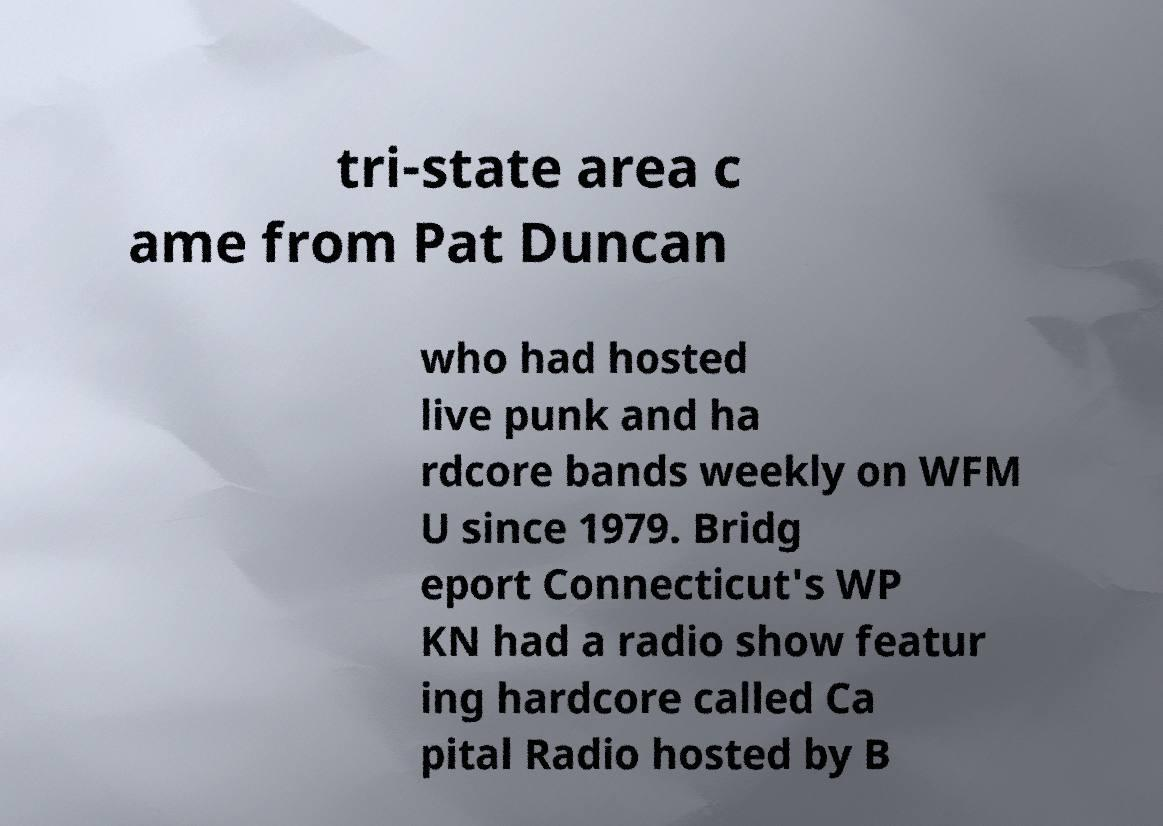Could you extract and type out the text from this image? tri-state area c ame from Pat Duncan who had hosted live punk and ha rdcore bands weekly on WFM U since 1979. Bridg eport Connecticut's WP KN had a radio show featur ing hardcore called Ca pital Radio hosted by B 